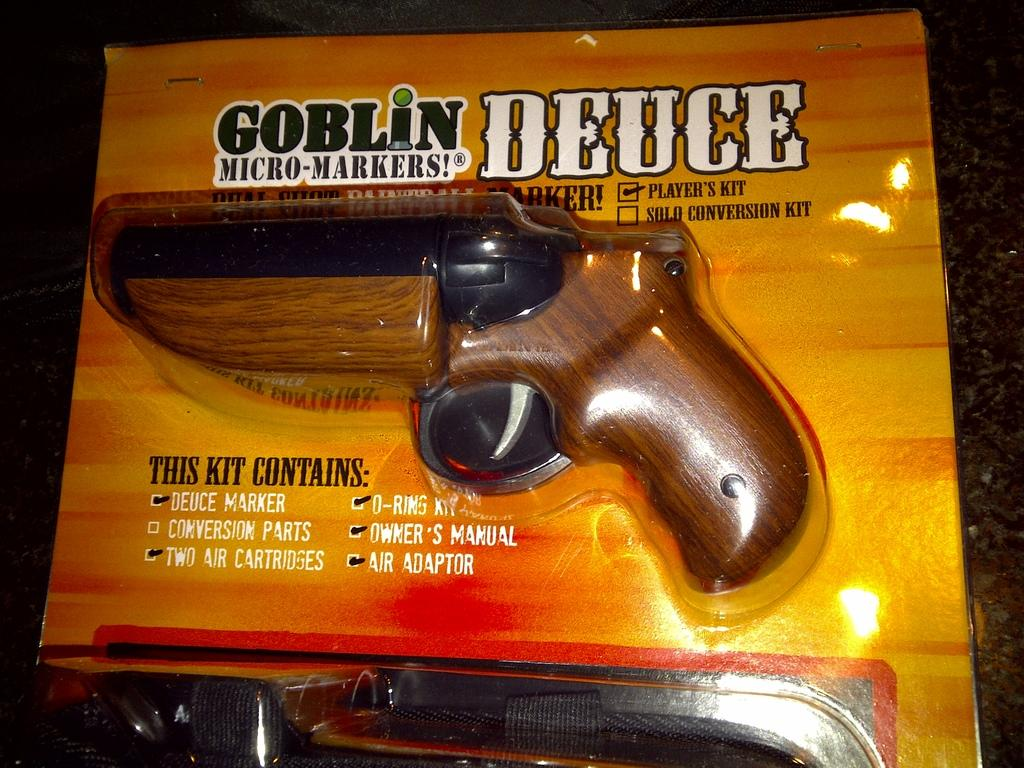What is the main object in the image? There is a kit in the image. What is inside the kit? The kit contains a gun. Where is the kit located in the image? The kit is placed on a platform. How many cubs can be seen playing with the jellyfish in the image? There are no cubs or jellyfish present in the image; it features a kit with a gun placed on a platform. 